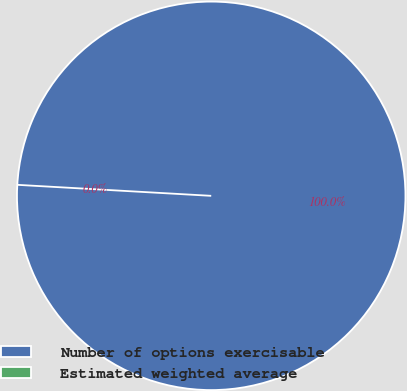<chart> <loc_0><loc_0><loc_500><loc_500><pie_chart><fcel>Number of options exercisable<fcel>Estimated weighted average<nl><fcel>100.0%<fcel>0.0%<nl></chart> 